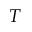Convert formula to latex. <formula><loc_0><loc_0><loc_500><loc_500>T</formula> 